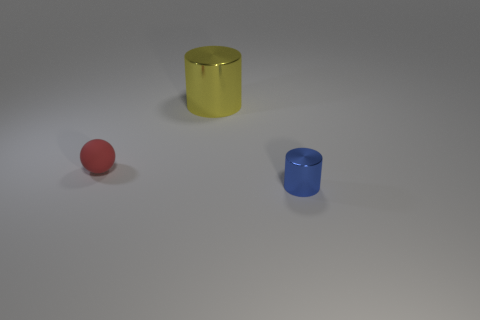Are there any other things that are the same material as the sphere?
Offer a terse response. No. Is there anything else that is the same size as the yellow object?
Provide a short and direct response. No. Is there anything else that has the same shape as the tiny red rubber object?
Your answer should be very brief. No. What color is the cylinder that is made of the same material as the large yellow thing?
Your answer should be very brief. Blue. There is a cylinder to the left of the thing in front of the small red rubber sphere; is there a ball that is behind it?
Keep it short and to the point. No. Are there fewer yellow things that are behind the tiny blue shiny cylinder than metal objects right of the red thing?
Provide a short and direct response. Yes. What number of other cylinders have the same material as the blue cylinder?
Provide a succinct answer. 1. Does the red matte thing have the same size as the metal cylinder behind the tiny rubber sphere?
Provide a short and direct response. No. There is a thing that is right of the metallic cylinder that is left of the tiny blue cylinder that is in front of the rubber sphere; what size is it?
Make the answer very short. Small. Is the number of large metal things behind the blue metallic thing greater than the number of tiny shiny things left of the yellow cylinder?
Your answer should be compact. Yes. 